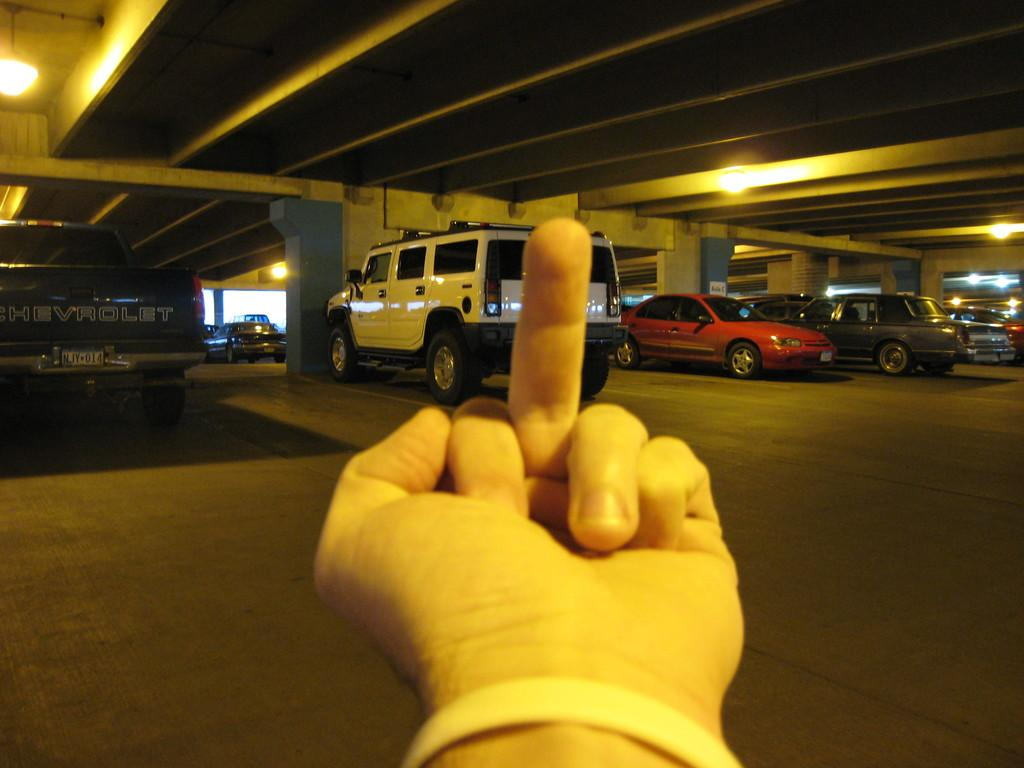What is the main subject in the foreground of the image? There is a person's hand in the foreground of the image. What can be seen in the background of the image? There are vehicles on the floor and lights on the ceiling in the background of the image. How many frogs are sitting on the furniture in the image? There are no frogs or furniture present in the image. What type of rock is visible in the background of the image? There is no rock visible in the image; it features a person's hand in the foreground and vehicles and lights in the background. 